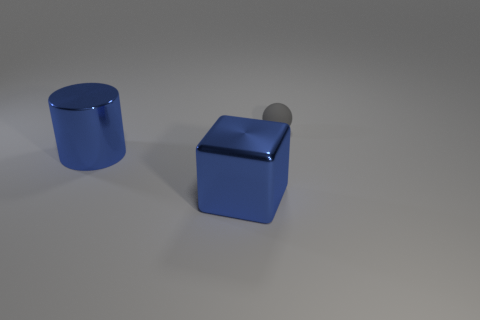Are there any other things that are made of the same material as the sphere?
Your answer should be compact. No. What number of other objects are there of the same shape as the gray object?
Your answer should be compact. 0. Is there any other thing that is the same size as the blue block?
Give a very brief answer. Yes. There is a shiny thing behind the blue cube; what is its color?
Offer a very short reply. Blue. The thing that is behind the blue thing behind the large blue metal object that is to the right of the metal cylinder is made of what material?
Offer a very short reply. Rubber. There is a thing that is to the left of the big blue metallic thing that is right of the big shiny cylinder; what is its size?
Offer a very short reply. Large. What number of other small balls have the same color as the tiny matte ball?
Provide a succinct answer. 0. Is the gray ball the same size as the blue shiny cylinder?
Give a very brief answer. No. What material is the small gray ball?
Your response must be concise. Rubber. There is a block that is made of the same material as the large blue cylinder; what color is it?
Keep it short and to the point. Blue. 